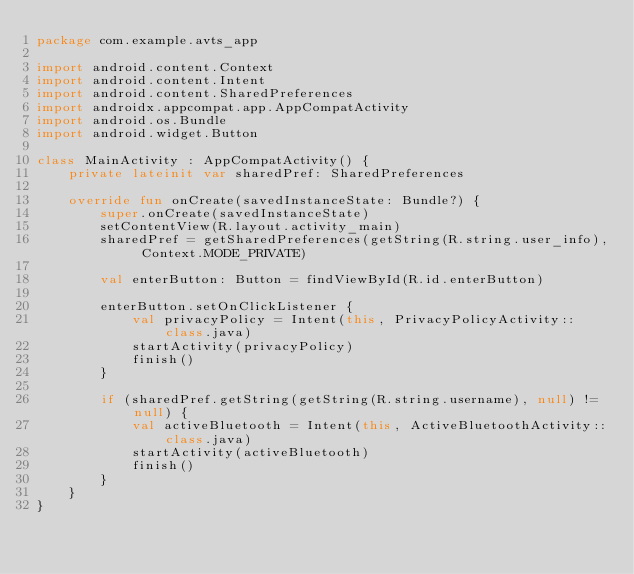Convert code to text. <code><loc_0><loc_0><loc_500><loc_500><_Kotlin_>package com.example.avts_app

import android.content.Context
import android.content.Intent
import android.content.SharedPreferences
import androidx.appcompat.app.AppCompatActivity
import android.os.Bundle
import android.widget.Button

class MainActivity : AppCompatActivity() {
    private lateinit var sharedPref: SharedPreferences

    override fun onCreate(savedInstanceState: Bundle?) {
        super.onCreate(savedInstanceState)
        setContentView(R.layout.activity_main)
        sharedPref = getSharedPreferences(getString(R.string.user_info), Context.MODE_PRIVATE)

        val enterButton: Button = findViewById(R.id.enterButton)

        enterButton.setOnClickListener {
            val privacyPolicy = Intent(this, PrivacyPolicyActivity::class.java)
            startActivity(privacyPolicy)
            finish()
        }

        if (sharedPref.getString(getString(R.string.username), null) != null) {
            val activeBluetooth = Intent(this, ActiveBluetoothActivity::class.java)
            startActivity(activeBluetooth)
            finish()
        }
    }
}</code> 